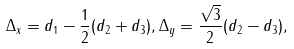<formula> <loc_0><loc_0><loc_500><loc_500>\Delta _ { x } = d _ { 1 } - \frac { 1 } { 2 } ( d _ { 2 } + d _ { 3 } ) , \Delta _ { y } = \frac { \sqrt { 3 } } { 2 } ( d _ { 2 } - d _ { 3 } ) ,</formula> 